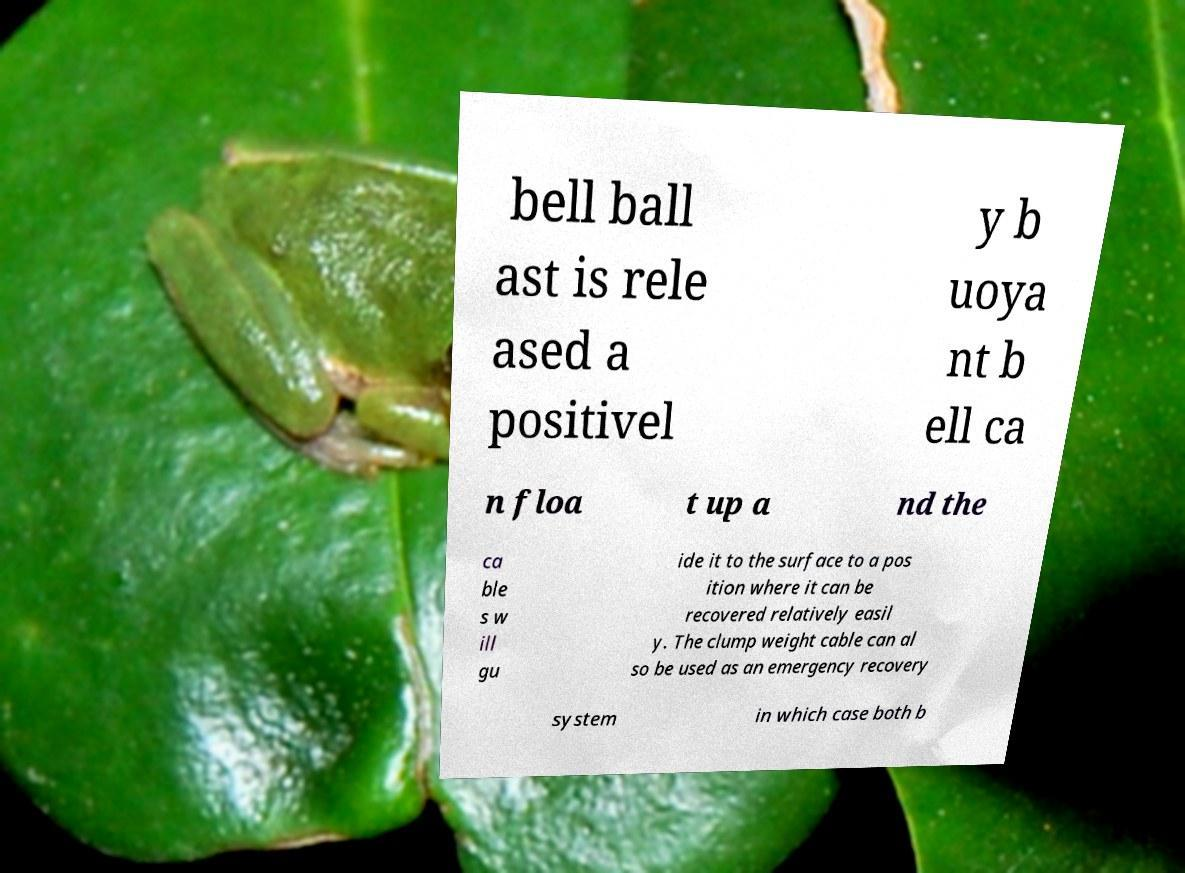Could you extract and type out the text from this image? bell ball ast is rele ased a positivel y b uoya nt b ell ca n floa t up a nd the ca ble s w ill gu ide it to the surface to a pos ition where it can be recovered relatively easil y. The clump weight cable can al so be used as an emergency recovery system in which case both b 